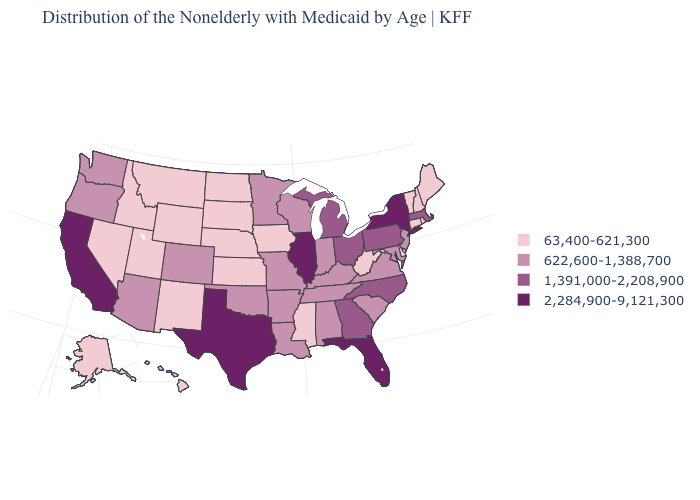Does Florida have the highest value in the USA?
Short answer required. Yes. What is the value of Iowa?
Keep it brief. 63,400-621,300. Does Michigan have a higher value than North Dakota?
Quick response, please. Yes. What is the lowest value in the USA?
Answer briefly. 63,400-621,300. Does the map have missing data?
Answer briefly. No. Among the states that border Maryland , does West Virginia have the lowest value?
Be succinct. Yes. Does California have a higher value than Texas?
Short answer required. No. Among the states that border Indiana , which have the highest value?
Write a very short answer. Illinois. Name the states that have a value in the range 63,400-621,300?
Be succinct. Alaska, Connecticut, Delaware, Hawaii, Idaho, Iowa, Kansas, Maine, Mississippi, Montana, Nebraska, Nevada, New Hampshire, New Mexico, North Dakota, Rhode Island, South Dakota, Utah, Vermont, West Virginia, Wyoming. Is the legend a continuous bar?
Keep it brief. No. Does Indiana have the highest value in the USA?
Give a very brief answer. No. Name the states that have a value in the range 2,284,900-9,121,300?
Quick response, please. California, Florida, Illinois, New York, Texas. What is the value of South Carolina?
Write a very short answer. 622,600-1,388,700. What is the value of Alaska?
Answer briefly. 63,400-621,300. What is the lowest value in the USA?
Give a very brief answer. 63,400-621,300. 